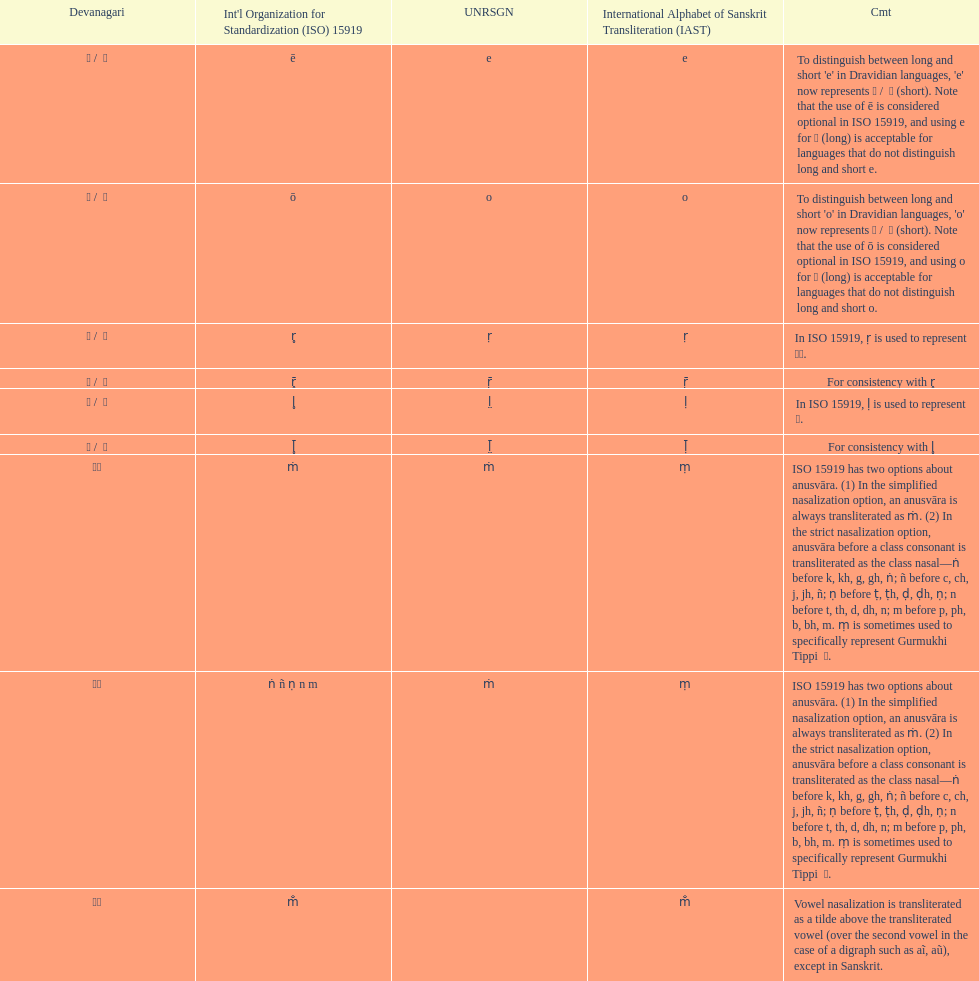Which devanagari transliteration is listed on the top of the table? ए / े. 